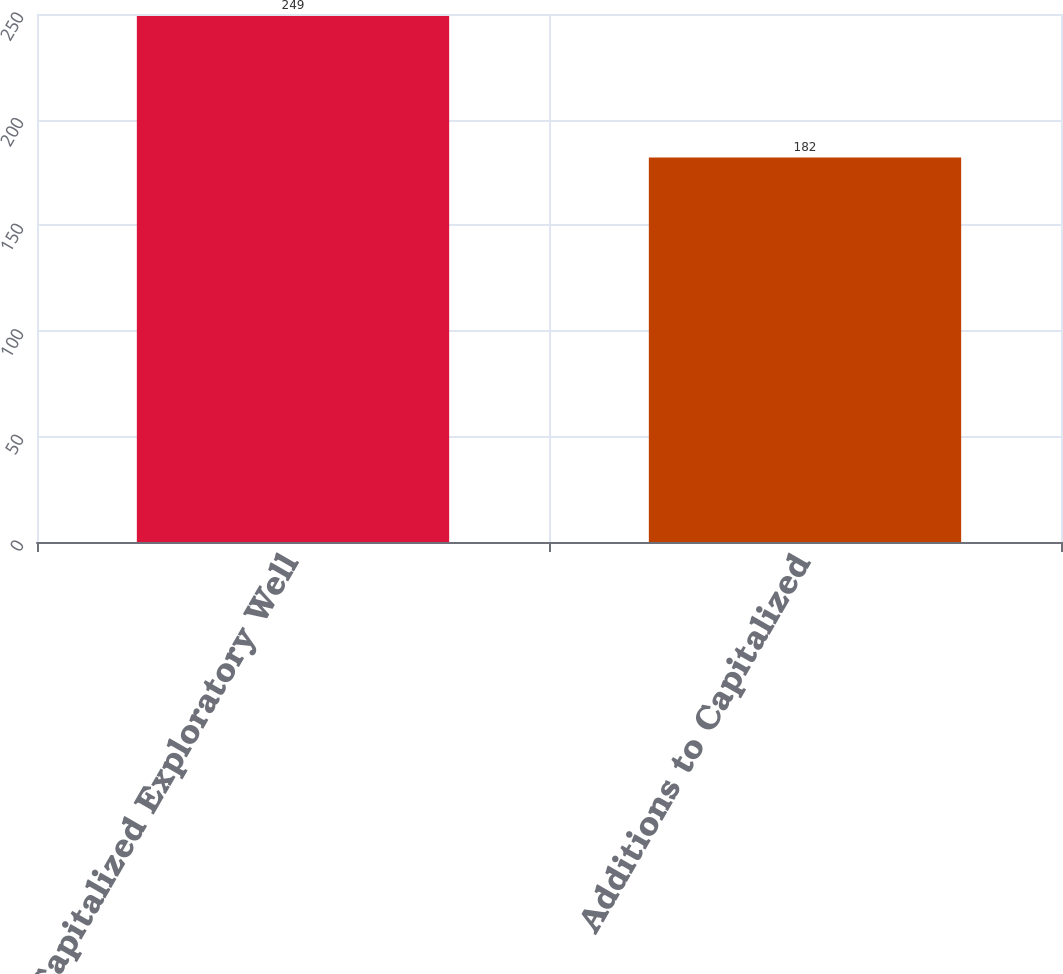Convert chart. <chart><loc_0><loc_0><loc_500><loc_500><bar_chart><fcel>Capitalized Exploratory Well<fcel>Additions to Capitalized<nl><fcel>249<fcel>182<nl></chart> 